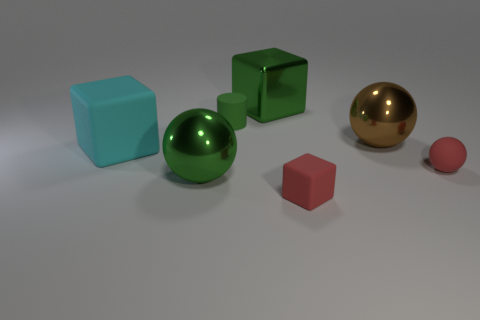Subtract all green metal balls. How many balls are left? 2 Subtract 0 gray balls. How many objects are left? 7 Subtract all balls. How many objects are left? 4 Subtract 1 balls. How many balls are left? 2 Subtract all red cylinders. Subtract all cyan balls. How many cylinders are left? 1 Subtract all yellow cylinders. How many gray blocks are left? 0 Subtract all matte balls. Subtract all big metal blocks. How many objects are left? 5 Add 7 red matte objects. How many red matte objects are left? 9 Add 3 tiny red things. How many tiny red things exist? 5 Add 2 tiny rubber cylinders. How many objects exist? 9 